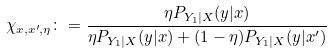Convert formula to latex. <formula><loc_0><loc_0><loc_500><loc_500>\chi _ { x , x ^ { \prime } , \eta } \colon = \frac { \eta P _ { Y _ { 1 } | X } ( y | x ) } { \eta P _ { Y _ { 1 } | X } ( y | x ) + ( 1 - \eta ) P _ { Y _ { 1 } | X } ( y | x ^ { \prime } ) }</formula> 